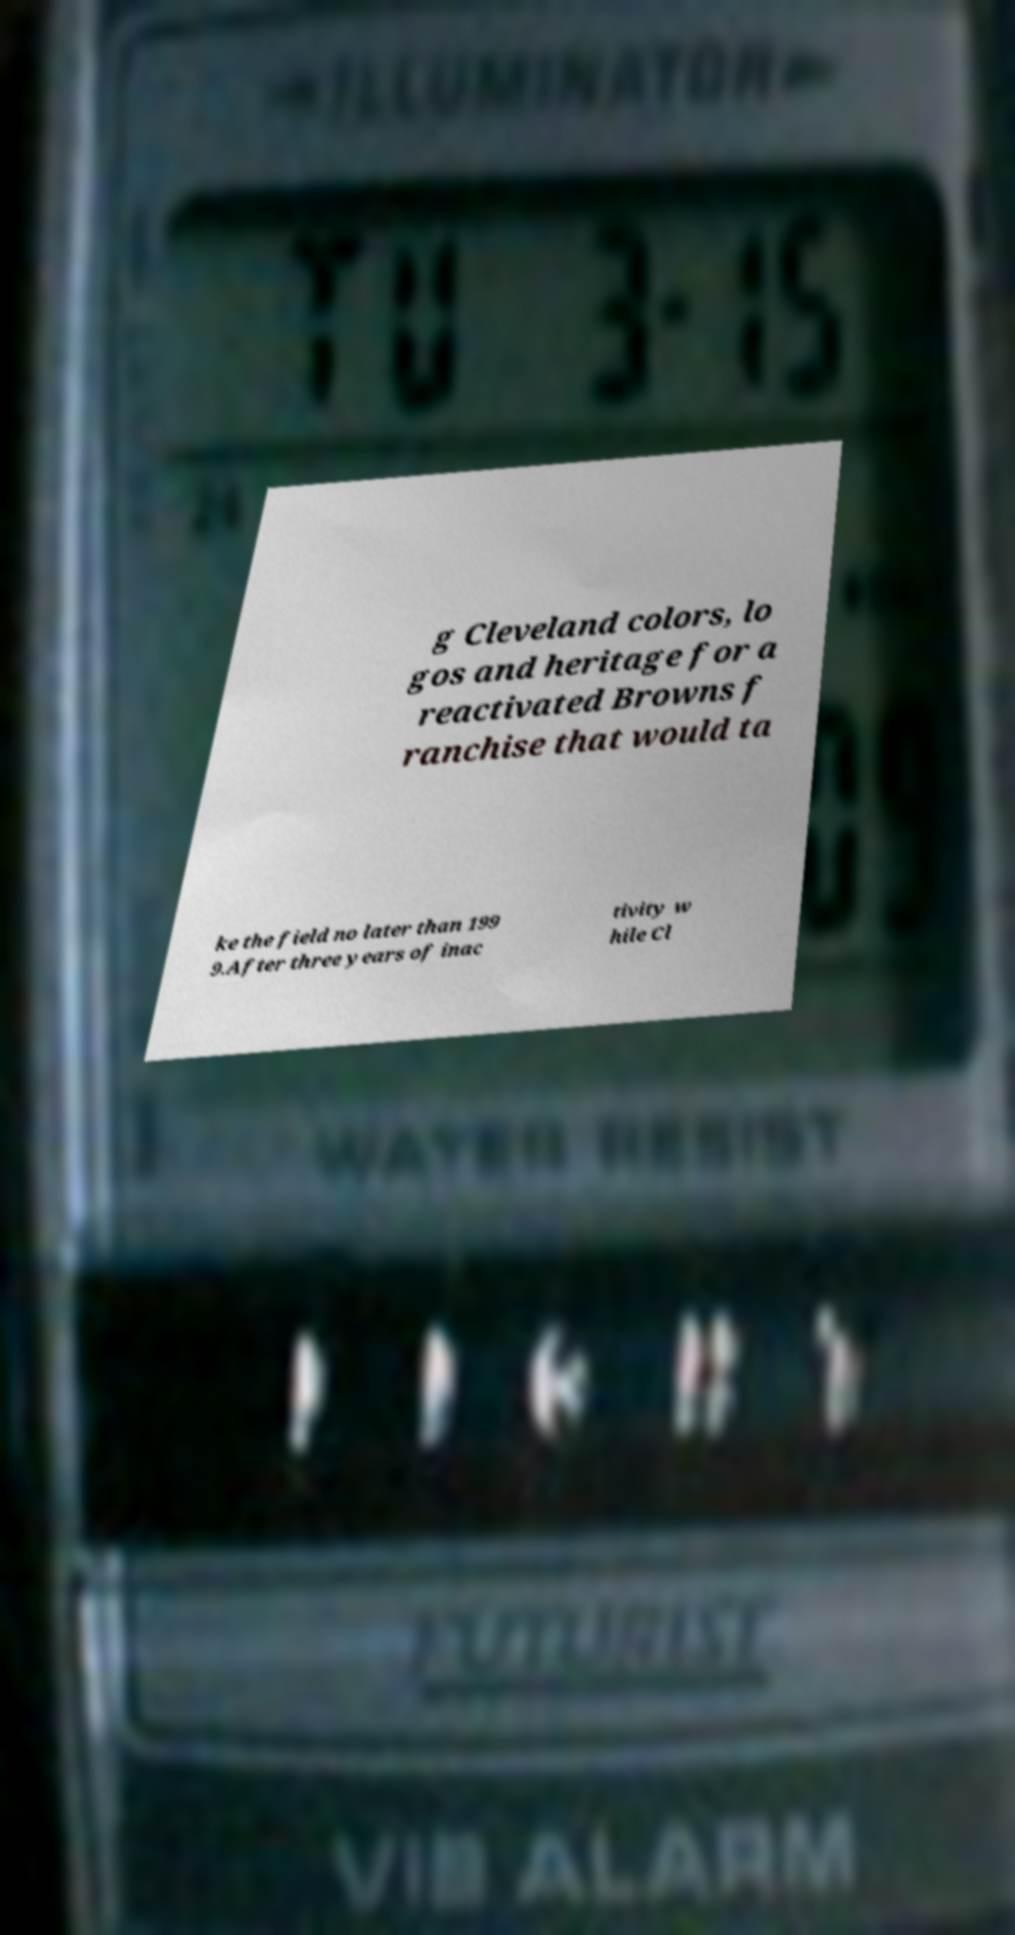What messages or text are displayed in this image? I need them in a readable, typed format. g Cleveland colors, lo gos and heritage for a reactivated Browns f ranchise that would ta ke the field no later than 199 9.After three years of inac tivity w hile Cl 